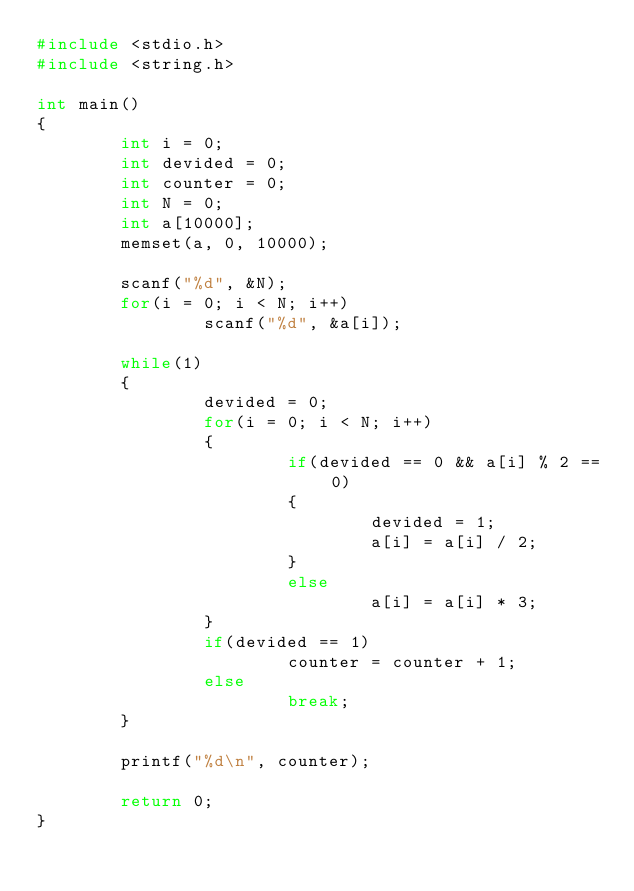<code> <loc_0><loc_0><loc_500><loc_500><_C_>#include <stdio.h>
#include <string.h>

int main()
{
        int i = 0;
        int devided = 0;
        int counter = 0;
        int N = 0;
        int a[10000];
        memset(a, 0, 10000);

        scanf("%d", &N);
        for(i = 0; i < N; i++)
                scanf("%d", &a[i]);

        while(1)
        {
                devided = 0;
                for(i = 0; i < N; i++)
                {
                        if(devided == 0 && a[i] % 2 == 0)
                        {
                                devided = 1;
                                a[i] = a[i] / 2;
                        }
                        else
                                a[i] = a[i] * 3;
                }
                if(devided == 1)
                        counter = counter + 1;
                else
                        break;
        }

        printf("%d\n", counter);

        return 0;
}</code> 